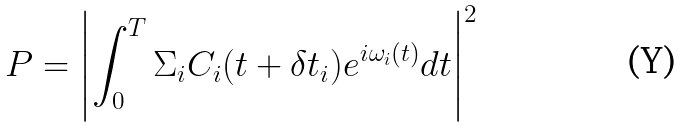<formula> <loc_0><loc_0><loc_500><loc_500>P = \left | \int _ { 0 } ^ { T } \Sigma _ { i } C _ { i } ( t + \delta t _ { i } ) e ^ { i \omega _ { i } ( t ) } d t \right | ^ { 2 }</formula> 